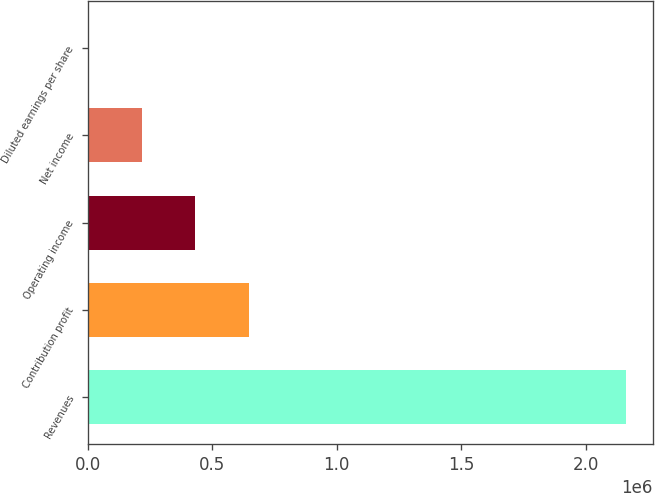Convert chart. <chart><loc_0><loc_0><loc_500><loc_500><bar_chart><fcel>Revenues<fcel>Contribution profit<fcel>Operating income<fcel>Net income<fcel>Diluted earnings per share<nl><fcel>2.16262e+06<fcel>648790<fcel>432527<fcel>216265<fcel>2.96<nl></chart> 